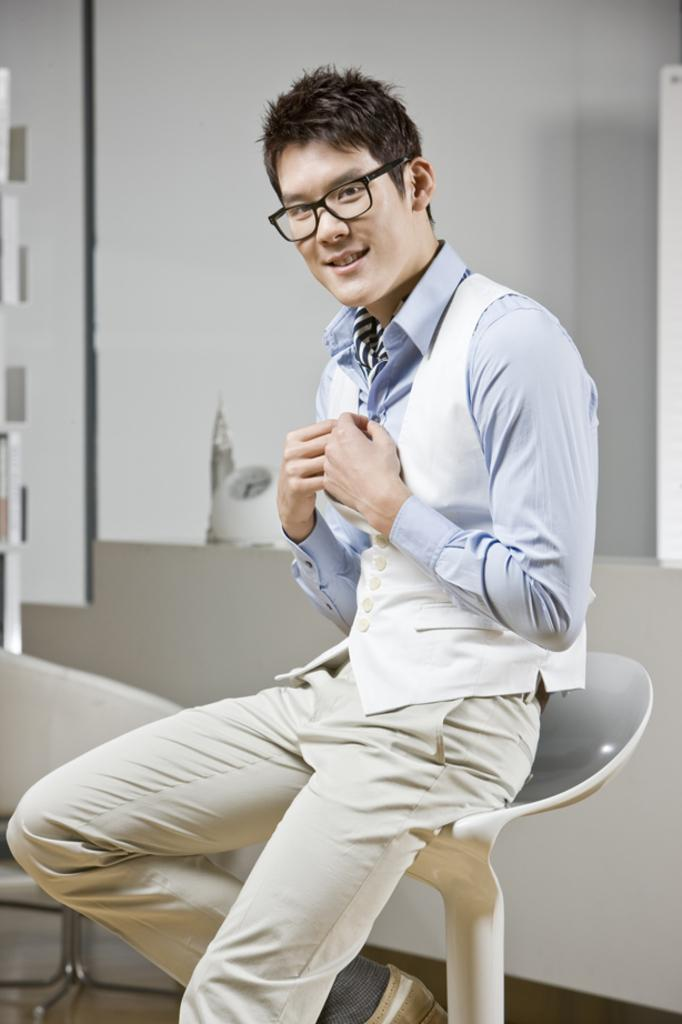Who or what is the main subject in the image? There is a person in the image. What is the person doing in the image? The person is sitting on a chair. What can be seen behind the person in the image? There is a wall in the background of the image. Are there any other objects or features visible in the background? Yes, there are objects visible in the background of the image. What type of wave can be seen crashing against the shore in the image? There is no wave present in the image; it features a person sitting on a chair with a wall in the background. 